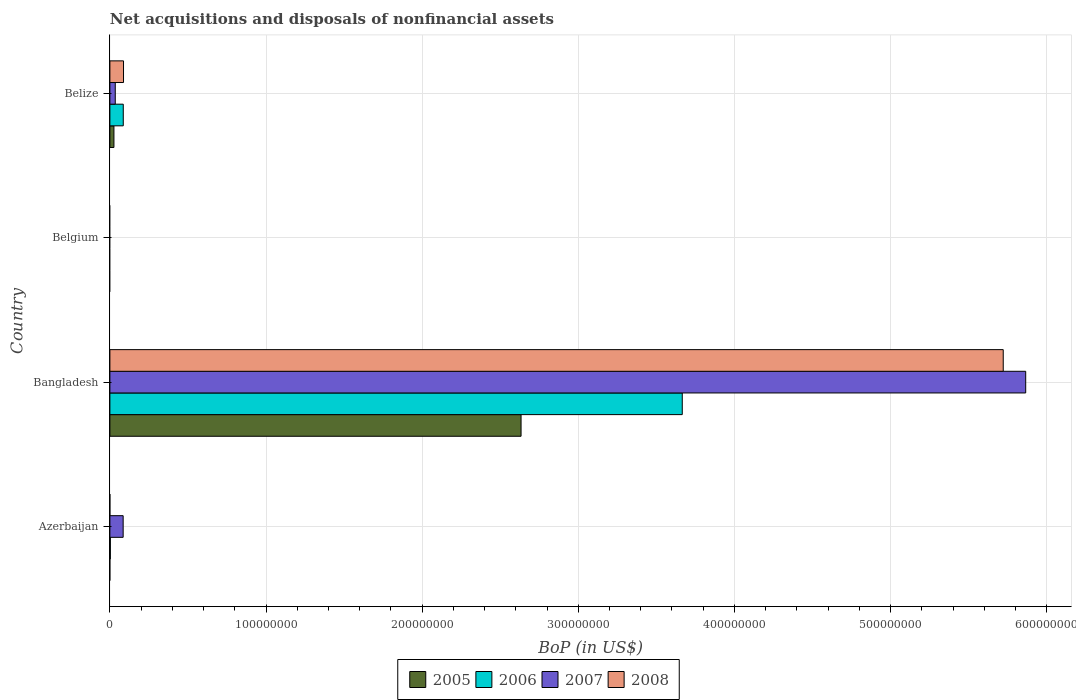How many bars are there on the 3rd tick from the top?
Your answer should be compact. 4. How many bars are there on the 2nd tick from the bottom?
Your answer should be very brief. 4. What is the label of the 4th group of bars from the top?
Ensure brevity in your answer.  Azerbaijan. Across all countries, what is the maximum Balance of Payments in 2007?
Make the answer very short. 5.87e+08. In which country was the Balance of Payments in 2005 maximum?
Offer a terse response. Bangladesh. What is the total Balance of Payments in 2008 in the graph?
Your response must be concise. 5.81e+08. What is the difference between the Balance of Payments in 2007 in Azerbaijan and that in Bangladesh?
Your answer should be compact. -5.78e+08. What is the difference between the Balance of Payments in 2007 in Belize and the Balance of Payments in 2006 in Belgium?
Your answer should be compact. 3.45e+06. What is the average Balance of Payments in 2007 per country?
Give a very brief answer. 1.50e+08. What is the difference between the Balance of Payments in 2006 and Balance of Payments in 2007 in Belize?
Provide a succinct answer. 5.12e+06. In how many countries, is the Balance of Payments in 2008 greater than 360000000 US$?
Keep it short and to the point. 1. What is the ratio of the Balance of Payments in 2008 in Bangladesh to that in Belize?
Keep it short and to the point. 65.57. What is the difference between the highest and the second highest Balance of Payments in 2006?
Offer a very short reply. 3.58e+08. What is the difference between the highest and the lowest Balance of Payments in 2006?
Keep it short and to the point. 3.67e+08. Are all the bars in the graph horizontal?
Provide a short and direct response. Yes. Does the graph contain any zero values?
Your answer should be compact. Yes. What is the title of the graph?
Provide a short and direct response. Net acquisitions and disposals of nonfinancial assets. Does "1989" appear as one of the legend labels in the graph?
Offer a terse response. No. What is the label or title of the X-axis?
Give a very brief answer. BoP (in US$). What is the label or title of the Y-axis?
Provide a short and direct response. Country. What is the BoP (in US$) in 2006 in Azerbaijan?
Your answer should be compact. 2.85e+05. What is the BoP (in US$) in 2007 in Azerbaijan?
Offer a very short reply. 8.49e+06. What is the BoP (in US$) in 2008 in Azerbaijan?
Your answer should be compact. 0. What is the BoP (in US$) of 2005 in Bangladesh?
Make the answer very short. 2.63e+08. What is the BoP (in US$) of 2006 in Bangladesh?
Ensure brevity in your answer.  3.67e+08. What is the BoP (in US$) of 2007 in Bangladesh?
Provide a short and direct response. 5.87e+08. What is the BoP (in US$) of 2008 in Bangladesh?
Keep it short and to the point. 5.72e+08. What is the BoP (in US$) of 2006 in Belgium?
Keep it short and to the point. 0. What is the BoP (in US$) of 2008 in Belgium?
Offer a terse response. 0. What is the BoP (in US$) of 2005 in Belize?
Provide a succinct answer. 2.59e+06. What is the BoP (in US$) in 2006 in Belize?
Give a very brief answer. 8.57e+06. What is the BoP (in US$) of 2007 in Belize?
Provide a succinct answer. 3.45e+06. What is the BoP (in US$) of 2008 in Belize?
Ensure brevity in your answer.  8.73e+06. Across all countries, what is the maximum BoP (in US$) in 2005?
Ensure brevity in your answer.  2.63e+08. Across all countries, what is the maximum BoP (in US$) in 2006?
Your answer should be compact. 3.67e+08. Across all countries, what is the maximum BoP (in US$) in 2007?
Ensure brevity in your answer.  5.87e+08. Across all countries, what is the maximum BoP (in US$) in 2008?
Offer a terse response. 5.72e+08. Across all countries, what is the minimum BoP (in US$) in 2005?
Provide a succinct answer. 0. Across all countries, what is the minimum BoP (in US$) in 2006?
Your answer should be very brief. 0. Across all countries, what is the minimum BoP (in US$) of 2007?
Your answer should be compact. 0. Across all countries, what is the minimum BoP (in US$) of 2008?
Your response must be concise. 0. What is the total BoP (in US$) of 2005 in the graph?
Ensure brevity in your answer.  2.66e+08. What is the total BoP (in US$) in 2006 in the graph?
Provide a short and direct response. 3.75e+08. What is the total BoP (in US$) in 2007 in the graph?
Offer a terse response. 5.98e+08. What is the total BoP (in US$) in 2008 in the graph?
Keep it short and to the point. 5.81e+08. What is the difference between the BoP (in US$) of 2006 in Azerbaijan and that in Bangladesh?
Your answer should be very brief. -3.66e+08. What is the difference between the BoP (in US$) of 2007 in Azerbaijan and that in Bangladesh?
Offer a very short reply. -5.78e+08. What is the difference between the BoP (in US$) of 2006 in Azerbaijan and that in Belize?
Provide a short and direct response. -8.28e+06. What is the difference between the BoP (in US$) in 2007 in Azerbaijan and that in Belize?
Your answer should be compact. 5.05e+06. What is the difference between the BoP (in US$) in 2005 in Bangladesh and that in Belize?
Provide a short and direct response. 2.61e+08. What is the difference between the BoP (in US$) of 2006 in Bangladesh and that in Belize?
Offer a very short reply. 3.58e+08. What is the difference between the BoP (in US$) of 2007 in Bangladesh and that in Belize?
Ensure brevity in your answer.  5.83e+08. What is the difference between the BoP (in US$) of 2008 in Bangladesh and that in Belize?
Offer a very short reply. 5.63e+08. What is the difference between the BoP (in US$) of 2006 in Azerbaijan and the BoP (in US$) of 2007 in Bangladesh?
Offer a very short reply. -5.86e+08. What is the difference between the BoP (in US$) in 2006 in Azerbaijan and the BoP (in US$) in 2008 in Bangladesh?
Make the answer very short. -5.72e+08. What is the difference between the BoP (in US$) of 2007 in Azerbaijan and the BoP (in US$) of 2008 in Bangladesh?
Ensure brevity in your answer.  -5.64e+08. What is the difference between the BoP (in US$) in 2006 in Azerbaijan and the BoP (in US$) in 2007 in Belize?
Provide a short and direct response. -3.16e+06. What is the difference between the BoP (in US$) in 2006 in Azerbaijan and the BoP (in US$) in 2008 in Belize?
Your answer should be very brief. -8.44e+06. What is the difference between the BoP (in US$) in 2007 in Azerbaijan and the BoP (in US$) in 2008 in Belize?
Provide a short and direct response. -2.35e+05. What is the difference between the BoP (in US$) of 2005 in Bangladesh and the BoP (in US$) of 2006 in Belize?
Your response must be concise. 2.55e+08. What is the difference between the BoP (in US$) in 2005 in Bangladesh and the BoP (in US$) in 2007 in Belize?
Keep it short and to the point. 2.60e+08. What is the difference between the BoP (in US$) of 2005 in Bangladesh and the BoP (in US$) of 2008 in Belize?
Provide a short and direct response. 2.55e+08. What is the difference between the BoP (in US$) in 2006 in Bangladesh and the BoP (in US$) in 2007 in Belize?
Provide a short and direct response. 3.63e+08. What is the difference between the BoP (in US$) of 2006 in Bangladesh and the BoP (in US$) of 2008 in Belize?
Offer a very short reply. 3.58e+08. What is the difference between the BoP (in US$) in 2007 in Bangladesh and the BoP (in US$) in 2008 in Belize?
Offer a terse response. 5.78e+08. What is the average BoP (in US$) of 2005 per country?
Keep it short and to the point. 6.65e+07. What is the average BoP (in US$) of 2006 per country?
Give a very brief answer. 9.39e+07. What is the average BoP (in US$) of 2007 per country?
Your response must be concise. 1.50e+08. What is the average BoP (in US$) of 2008 per country?
Give a very brief answer. 1.45e+08. What is the difference between the BoP (in US$) in 2006 and BoP (in US$) in 2007 in Azerbaijan?
Give a very brief answer. -8.21e+06. What is the difference between the BoP (in US$) in 2005 and BoP (in US$) in 2006 in Bangladesh?
Keep it short and to the point. -1.03e+08. What is the difference between the BoP (in US$) in 2005 and BoP (in US$) in 2007 in Bangladesh?
Your answer should be compact. -3.23e+08. What is the difference between the BoP (in US$) in 2005 and BoP (in US$) in 2008 in Bangladesh?
Your answer should be very brief. -3.09e+08. What is the difference between the BoP (in US$) of 2006 and BoP (in US$) of 2007 in Bangladesh?
Your response must be concise. -2.20e+08. What is the difference between the BoP (in US$) of 2006 and BoP (in US$) of 2008 in Bangladesh?
Your answer should be compact. -2.06e+08. What is the difference between the BoP (in US$) in 2007 and BoP (in US$) in 2008 in Bangladesh?
Provide a short and direct response. 1.44e+07. What is the difference between the BoP (in US$) of 2005 and BoP (in US$) of 2006 in Belize?
Your answer should be very brief. -5.98e+06. What is the difference between the BoP (in US$) in 2005 and BoP (in US$) in 2007 in Belize?
Offer a very short reply. -8.56e+05. What is the difference between the BoP (in US$) of 2005 and BoP (in US$) of 2008 in Belize?
Provide a short and direct response. -6.14e+06. What is the difference between the BoP (in US$) in 2006 and BoP (in US$) in 2007 in Belize?
Give a very brief answer. 5.12e+06. What is the difference between the BoP (in US$) of 2006 and BoP (in US$) of 2008 in Belize?
Offer a very short reply. -1.61e+05. What is the difference between the BoP (in US$) in 2007 and BoP (in US$) in 2008 in Belize?
Your response must be concise. -5.28e+06. What is the ratio of the BoP (in US$) of 2006 in Azerbaijan to that in Bangladesh?
Offer a terse response. 0. What is the ratio of the BoP (in US$) of 2007 in Azerbaijan to that in Bangladesh?
Ensure brevity in your answer.  0.01. What is the ratio of the BoP (in US$) in 2007 in Azerbaijan to that in Belize?
Your answer should be compact. 2.46. What is the ratio of the BoP (in US$) of 2005 in Bangladesh to that in Belize?
Give a very brief answer. 101.69. What is the ratio of the BoP (in US$) of 2006 in Bangladesh to that in Belize?
Give a very brief answer. 42.8. What is the ratio of the BoP (in US$) of 2007 in Bangladesh to that in Belize?
Make the answer very short. 170.21. What is the ratio of the BoP (in US$) of 2008 in Bangladesh to that in Belize?
Offer a very short reply. 65.57. What is the difference between the highest and the second highest BoP (in US$) in 2006?
Offer a terse response. 3.58e+08. What is the difference between the highest and the second highest BoP (in US$) in 2007?
Provide a short and direct response. 5.78e+08. What is the difference between the highest and the lowest BoP (in US$) in 2005?
Keep it short and to the point. 2.63e+08. What is the difference between the highest and the lowest BoP (in US$) of 2006?
Offer a very short reply. 3.67e+08. What is the difference between the highest and the lowest BoP (in US$) in 2007?
Ensure brevity in your answer.  5.87e+08. What is the difference between the highest and the lowest BoP (in US$) of 2008?
Your response must be concise. 5.72e+08. 